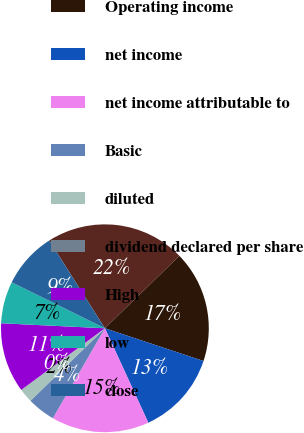Convert chart. <chart><loc_0><loc_0><loc_500><loc_500><pie_chart><fcel>Revenue<fcel>Operating income<fcel>net income<fcel>net income attributable to<fcel>Basic<fcel>diluted<fcel>dividend declared per share<fcel>High<fcel>low<fcel>close<nl><fcel>21.72%<fcel>17.38%<fcel>13.04%<fcel>15.21%<fcel>4.36%<fcel>2.18%<fcel>0.01%<fcel>10.87%<fcel>6.53%<fcel>8.7%<nl></chart> 